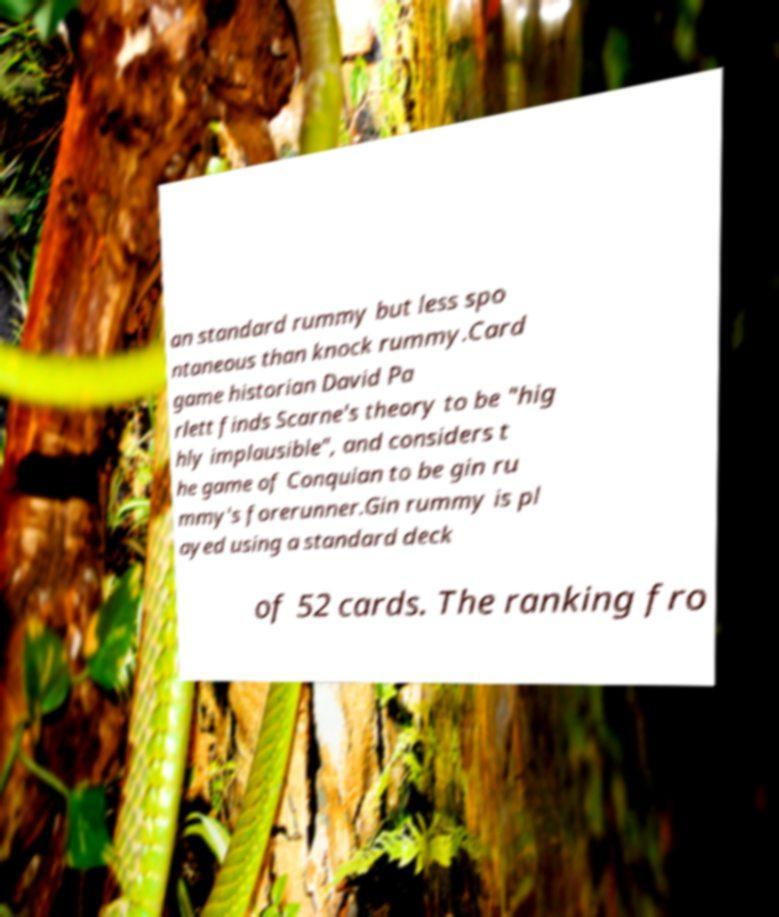Can you accurately transcribe the text from the provided image for me? an standard rummy but less spo ntaneous than knock rummy.Card game historian David Pa rlett finds Scarne's theory to be "hig hly implausible", and considers t he game of Conquian to be gin ru mmy's forerunner.Gin rummy is pl ayed using a standard deck of 52 cards. The ranking fro 